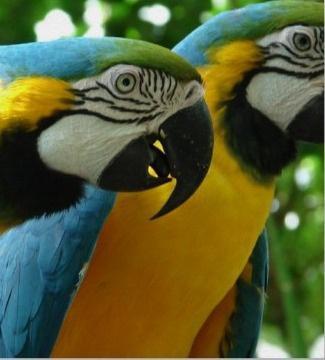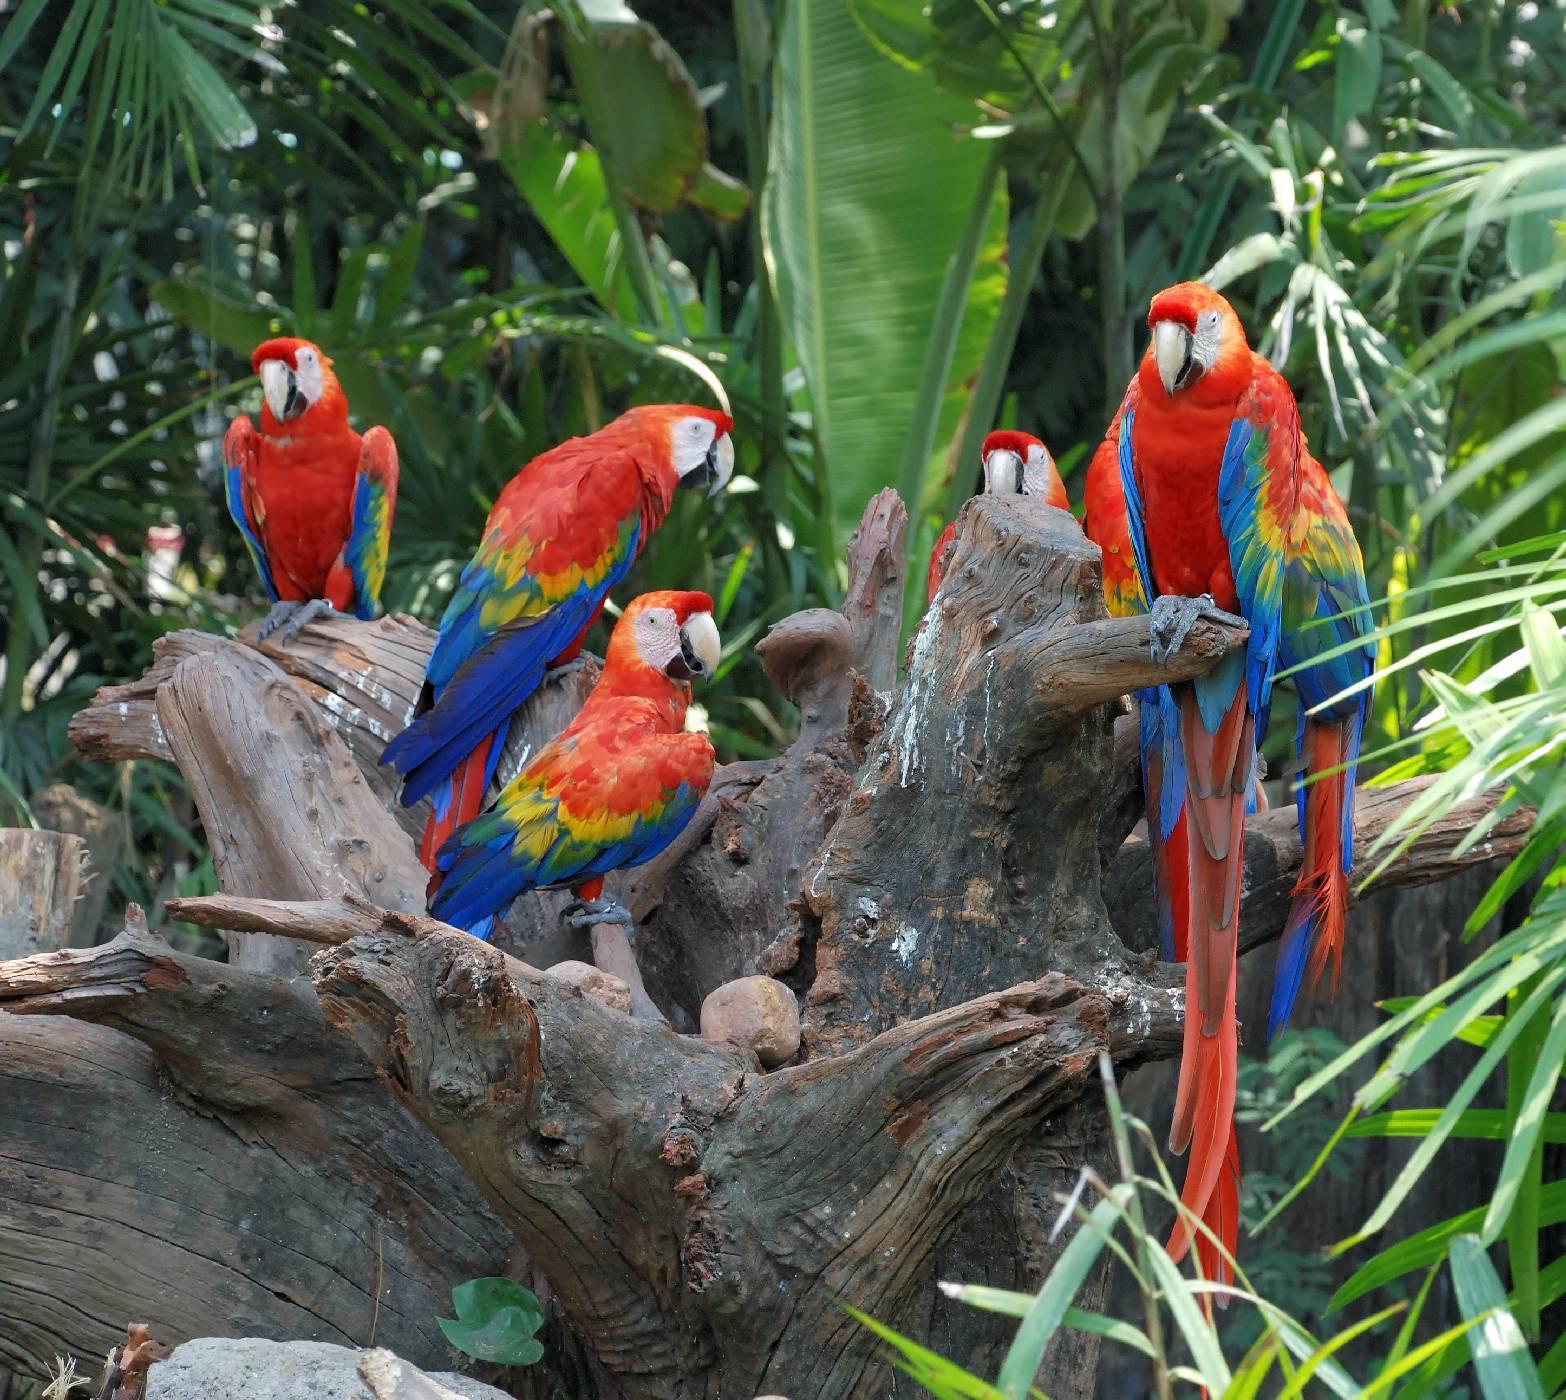The first image is the image on the left, the second image is the image on the right. For the images displayed, is the sentence "At least one image contains no more than 3 birds." factually correct? Answer yes or no. Yes. 